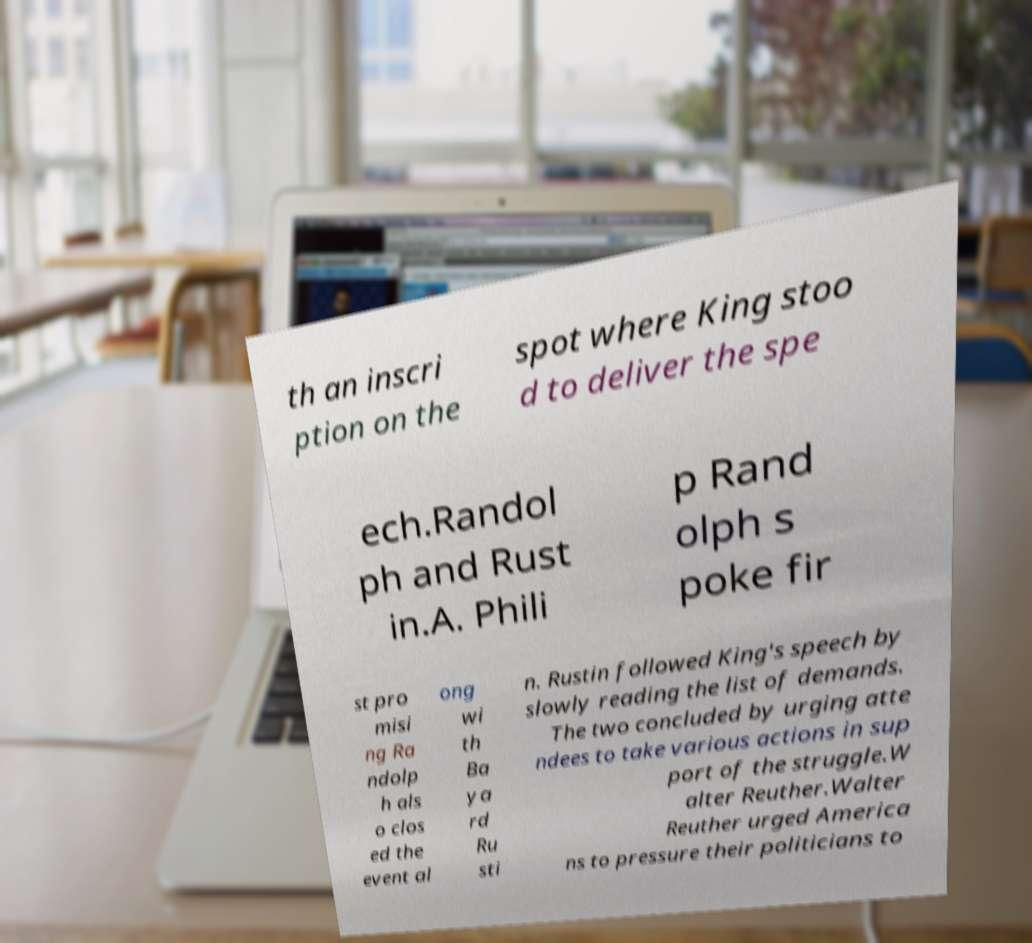Please read and relay the text visible in this image. What does it say? th an inscri ption on the spot where King stoo d to deliver the spe ech.Randol ph and Rust in.A. Phili p Rand olph s poke fir st pro misi ng Ra ndolp h als o clos ed the event al ong wi th Ba ya rd Ru sti n. Rustin followed King's speech by slowly reading the list of demands. The two concluded by urging atte ndees to take various actions in sup port of the struggle.W alter Reuther.Walter Reuther urged America ns to pressure their politicians to 